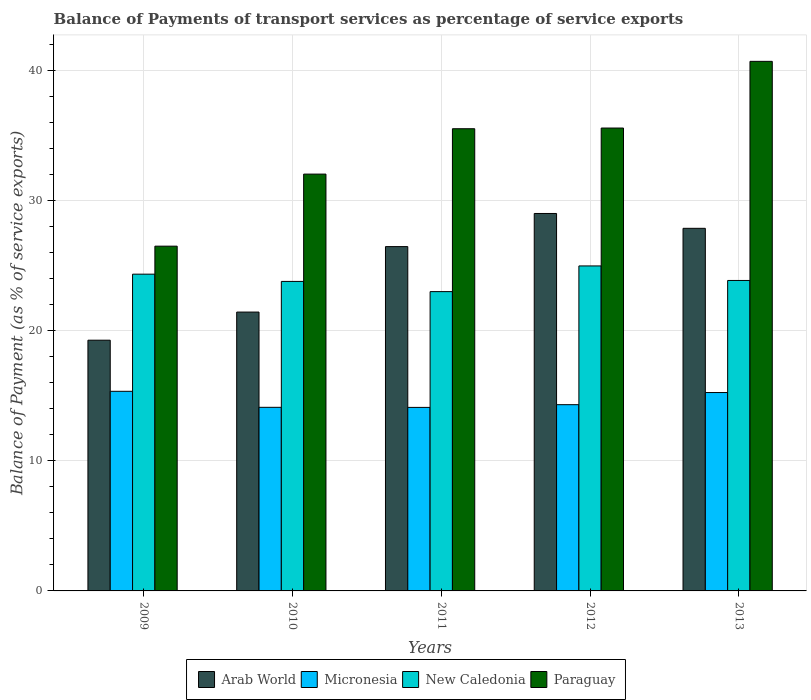How many groups of bars are there?
Give a very brief answer. 5. What is the balance of payments of transport services in Paraguay in 2009?
Provide a succinct answer. 26.48. Across all years, what is the maximum balance of payments of transport services in Arab World?
Make the answer very short. 28.99. Across all years, what is the minimum balance of payments of transport services in Paraguay?
Your response must be concise. 26.48. In which year was the balance of payments of transport services in Micronesia minimum?
Keep it short and to the point. 2011. What is the total balance of payments of transport services in Micronesia in the graph?
Keep it short and to the point. 73.06. What is the difference between the balance of payments of transport services in New Caledonia in 2009 and that in 2013?
Your answer should be compact. 0.48. What is the difference between the balance of payments of transport services in Micronesia in 2009 and the balance of payments of transport services in Arab World in 2013?
Keep it short and to the point. -12.52. What is the average balance of payments of transport services in New Caledonia per year?
Give a very brief answer. 23.98. In the year 2011, what is the difference between the balance of payments of transport services in Micronesia and balance of payments of transport services in Arab World?
Your answer should be compact. -12.35. What is the ratio of the balance of payments of transport services in Paraguay in 2010 to that in 2011?
Your response must be concise. 0.9. Is the balance of payments of transport services in Arab World in 2009 less than that in 2010?
Make the answer very short. Yes. Is the difference between the balance of payments of transport services in Micronesia in 2012 and 2013 greater than the difference between the balance of payments of transport services in Arab World in 2012 and 2013?
Offer a very short reply. No. What is the difference between the highest and the second highest balance of payments of transport services in Arab World?
Your response must be concise. 1.14. What is the difference between the highest and the lowest balance of payments of transport services in Paraguay?
Ensure brevity in your answer.  14.19. In how many years, is the balance of payments of transport services in Paraguay greater than the average balance of payments of transport services in Paraguay taken over all years?
Provide a succinct answer. 3. Is the sum of the balance of payments of transport services in Paraguay in 2010 and 2013 greater than the maximum balance of payments of transport services in New Caledonia across all years?
Ensure brevity in your answer.  Yes. What does the 1st bar from the left in 2011 represents?
Provide a succinct answer. Arab World. What does the 3rd bar from the right in 2013 represents?
Your answer should be compact. Micronesia. Are all the bars in the graph horizontal?
Your answer should be very brief. No. How many years are there in the graph?
Offer a very short reply. 5. Are the values on the major ticks of Y-axis written in scientific E-notation?
Give a very brief answer. No. Does the graph contain any zero values?
Ensure brevity in your answer.  No. Does the graph contain grids?
Keep it short and to the point. Yes. Where does the legend appear in the graph?
Make the answer very short. Bottom center. How many legend labels are there?
Your answer should be very brief. 4. How are the legend labels stacked?
Provide a short and direct response. Horizontal. What is the title of the graph?
Offer a terse response. Balance of Payments of transport services as percentage of service exports. What is the label or title of the X-axis?
Ensure brevity in your answer.  Years. What is the label or title of the Y-axis?
Give a very brief answer. Balance of Payment (as % of service exports). What is the Balance of Payment (as % of service exports) of Arab World in 2009?
Offer a terse response. 19.25. What is the Balance of Payment (as % of service exports) in Micronesia in 2009?
Your answer should be compact. 15.33. What is the Balance of Payment (as % of service exports) of New Caledonia in 2009?
Ensure brevity in your answer.  24.33. What is the Balance of Payment (as % of service exports) of Paraguay in 2009?
Offer a terse response. 26.48. What is the Balance of Payment (as % of service exports) of Arab World in 2010?
Offer a very short reply. 21.41. What is the Balance of Payment (as % of service exports) in Micronesia in 2010?
Provide a short and direct response. 14.1. What is the Balance of Payment (as % of service exports) of New Caledonia in 2010?
Keep it short and to the point. 23.77. What is the Balance of Payment (as % of service exports) in Paraguay in 2010?
Your answer should be compact. 32.01. What is the Balance of Payment (as % of service exports) of Arab World in 2011?
Your response must be concise. 26.44. What is the Balance of Payment (as % of service exports) in Micronesia in 2011?
Offer a very short reply. 14.09. What is the Balance of Payment (as % of service exports) of New Caledonia in 2011?
Your answer should be compact. 22.98. What is the Balance of Payment (as % of service exports) in Paraguay in 2011?
Your response must be concise. 35.49. What is the Balance of Payment (as % of service exports) of Arab World in 2012?
Provide a short and direct response. 28.99. What is the Balance of Payment (as % of service exports) of Micronesia in 2012?
Make the answer very short. 14.3. What is the Balance of Payment (as % of service exports) in New Caledonia in 2012?
Offer a terse response. 24.96. What is the Balance of Payment (as % of service exports) in Paraguay in 2012?
Give a very brief answer. 35.55. What is the Balance of Payment (as % of service exports) of Arab World in 2013?
Provide a succinct answer. 27.85. What is the Balance of Payment (as % of service exports) of Micronesia in 2013?
Offer a terse response. 15.23. What is the Balance of Payment (as % of service exports) of New Caledonia in 2013?
Offer a very short reply. 23.84. What is the Balance of Payment (as % of service exports) of Paraguay in 2013?
Ensure brevity in your answer.  40.67. Across all years, what is the maximum Balance of Payment (as % of service exports) in Arab World?
Your answer should be very brief. 28.99. Across all years, what is the maximum Balance of Payment (as % of service exports) in Micronesia?
Offer a very short reply. 15.33. Across all years, what is the maximum Balance of Payment (as % of service exports) of New Caledonia?
Your answer should be compact. 24.96. Across all years, what is the maximum Balance of Payment (as % of service exports) in Paraguay?
Your response must be concise. 40.67. Across all years, what is the minimum Balance of Payment (as % of service exports) in Arab World?
Make the answer very short. 19.25. Across all years, what is the minimum Balance of Payment (as % of service exports) of Micronesia?
Make the answer very short. 14.09. Across all years, what is the minimum Balance of Payment (as % of service exports) of New Caledonia?
Make the answer very short. 22.98. Across all years, what is the minimum Balance of Payment (as % of service exports) in Paraguay?
Provide a succinct answer. 26.48. What is the total Balance of Payment (as % of service exports) in Arab World in the graph?
Provide a short and direct response. 123.94. What is the total Balance of Payment (as % of service exports) in Micronesia in the graph?
Keep it short and to the point. 73.06. What is the total Balance of Payment (as % of service exports) in New Caledonia in the graph?
Make the answer very short. 119.88. What is the total Balance of Payment (as % of service exports) in Paraguay in the graph?
Offer a very short reply. 170.19. What is the difference between the Balance of Payment (as % of service exports) in Arab World in 2009 and that in 2010?
Make the answer very short. -2.16. What is the difference between the Balance of Payment (as % of service exports) in Micronesia in 2009 and that in 2010?
Your response must be concise. 1.23. What is the difference between the Balance of Payment (as % of service exports) of New Caledonia in 2009 and that in 2010?
Your answer should be compact. 0.56. What is the difference between the Balance of Payment (as % of service exports) in Paraguay in 2009 and that in 2010?
Make the answer very short. -5.53. What is the difference between the Balance of Payment (as % of service exports) in Arab World in 2009 and that in 2011?
Your answer should be compact. -7.19. What is the difference between the Balance of Payment (as % of service exports) in Micronesia in 2009 and that in 2011?
Provide a succinct answer. 1.24. What is the difference between the Balance of Payment (as % of service exports) of New Caledonia in 2009 and that in 2011?
Your response must be concise. 1.34. What is the difference between the Balance of Payment (as % of service exports) of Paraguay in 2009 and that in 2011?
Your response must be concise. -9.02. What is the difference between the Balance of Payment (as % of service exports) of Arab World in 2009 and that in 2012?
Provide a succinct answer. -9.73. What is the difference between the Balance of Payment (as % of service exports) of Micronesia in 2009 and that in 2012?
Give a very brief answer. 1.03. What is the difference between the Balance of Payment (as % of service exports) in New Caledonia in 2009 and that in 2012?
Make the answer very short. -0.63. What is the difference between the Balance of Payment (as % of service exports) of Paraguay in 2009 and that in 2012?
Make the answer very short. -9.07. What is the difference between the Balance of Payment (as % of service exports) in Arab World in 2009 and that in 2013?
Give a very brief answer. -8.59. What is the difference between the Balance of Payment (as % of service exports) in Micronesia in 2009 and that in 2013?
Keep it short and to the point. 0.1. What is the difference between the Balance of Payment (as % of service exports) of New Caledonia in 2009 and that in 2013?
Provide a succinct answer. 0.48. What is the difference between the Balance of Payment (as % of service exports) in Paraguay in 2009 and that in 2013?
Your response must be concise. -14.19. What is the difference between the Balance of Payment (as % of service exports) in Arab World in 2010 and that in 2011?
Your response must be concise. -5.03. What is the difference between the Balance of Payment (as % of service exports) of Micronesia in 2010 and that in 2011?
Make the answer very short. 0.01. What is the difference between the Balance of Payment (as % of service exports) in New Caledonia in 2010 and that in 2011?
Provide a succinct answer. 0.78. What is the difference between the Balance of Payment (as % of service exports) of Paraguay in 2010 and that in 2011?
Give a very brief answer. -3.49. What is the difference between the Balance of Payment (as % of service exports) of Arab World in 2010 and that in 2012?
Provide a succinct answer. -7.57. What is the difference between the Balance of Payment (as % of service exports) in Micronesia in 2010 and that in 2012?
Provide a short and direct response. -0.2. What is the difference between the Balance of Payment (as % of service exports) in New Caledonia in 2010 and that in 2012?
Your answer should be compact. -1.19. What is the difference between the Balance of Payment (as % of service exports) in Paraguay in 2010 and that in 2012?
Provide a short and direct response. -3.54. What is the difference between the Balance of Payment (as % of service exports) of Arab World in 2010 and that in 2013?
Provide a succinct answer. -6.43. What is the difference between the Balance of Payment (as % of service exports) of Micronesia in 2010 and that in 2013?
Keep it short and to the point. -1.14. What is the difference between the Balance of Payment (as % of service exports) of New Caledonia in 2010 and that in 2013?
Your answer should be very brief. -0.07. What is the difference between the Balance of Payment (as % of service exports) of Paraguay in 2010 and that in 2013?
Offer a terse response. -8.66. What is the difference between the Balance of Payment (as % of service exports) in Arab World in 2011 and that in 2012?
Offer a very short reply. -2.54. What is the difference between the Balance of Payment (as % of service exports) in Micronesia in 2011 and that in 2012?
Offer a very short reply. -0.21. What is the difference between the Balance of Payment (as % of service exports) of New Caledonia in 2011 and that in 2012?
Your answer should be very brief. -1.97. What is the difference between the Balance of Payment (as % of service exports) in Paraguay in 2011 and that in 2012?
Your response must be concise. -0.05. What is the difference between the Balance of Payment (as % of service exports) in Arab World in 2011 and that in 2013?
Make the answer very short. -1.4. What is the difference between the Balance of Payment (as % of service exports) in Micronesia in 2011 and that in 2013?
Provide a succinct answer. -1.14. What is the difference between the Balance of Payment (as % of service exports) of New Caledonia in 2011 and that in 2013?
Give a very brief answer. -0.86. What is the difference between the Balance of Payment (as % of service exports) in Paraguay in 2011 and that in 2013?
Your answer should be very brief. -5.17. What is the difference between the Balance of Payment (as % of service exports) in Arab World in 2012 and that in 2013?
Provide a short and direct response. 1.14. What is the difference between the Balance of Payment (as % of service exports) of Micronesia in 2012 and that in 2013?
Make the answer very short. -0.93. What is the difference between the Balance of Payment (as % of service exports) of New Caledonia in 2012 and that in 2013?
Offer a terse response. 1.12. What is the difference between the Balance of Payment (as % of service exports) in Paraguay in 2012 and that in 2013?
Give a very brief answer. -5.12. What is the difference between the Balance of Payment (as % of service exports) in Arab World in 2009 and the Balance of Payment (as % of service exports) in Micronesia in 2010?
Your answer should be compact. 5.16. What is the difference between the Balance of Payment (as % of service exports) in Arab World in 2009 and the Balance of Payment (as % of service exports) in New Caledonia in 2010?
Ensure brevity in your answer.  -4.51. What is the difference between the Balance of Payment (as % of service exports) of Arab World in 2009 and the Balance of Payment (as % of service exports) of Paraguay in 2010?
Provide a succinct answer. -12.75. What is the difference between the Balance of Payment (as % of service exports) in Micronesia in 2009 and the Balance of Payment (as % of service exports) in New Caledonia in 2010?
Give a very brief answer. -8.44. What is the difference between the Balance of Payment (as % of service exports) of Micronesia in 2009 and the Balance of Payment (as % of service exports) of Paraguay in 2010?
Provide a short and direct response. -16.68. What is the difference between the Balance of Payment (as % of service exports) of New Caledonia in 2009 and the Balance of Payment (as % of service exports) of Paraguay in 2010?
Your answer should be compact. -7.68. What is the difference between the Balance of Payment (as % of service exports) of Arab World in 2009 and the Balance of Payment (as % of service exports) of Micronesia in 2011?
Your answer should be very brief. 5.16. What is the difference between the Balance of Payment (as % of service exports) of Arab World in 2009 and the Balance of Payment (as % of service exports) of New Caledonia in 2011?
Give a very brief answer. -3.73. What is the difference between the Balance of Payment (as % of service exports) in Arab World in 2009 and the Balance of Payment (as % of service exports) in Paraguay in 2011?
Provide a succinct answer. -16.24. What is the difference between the Balance of Payment (as % of service exports) in Micronesia in 2009 and the Balance of Payment (as % of service exports) in New Caledonia in 2011?
Provide a short and direct response. -7.66. What is the difference between the Balance of Payment (as % of service exports) of Micronesia in 2009 and the Balance of Payment (as % of service exports) of Paraguay in 2011?
Your answer should be compact. -20.16. What is the difference between the Balance of Payment (as % of service exports) of New Caledonia in 2009 and the Balance of Payment (as % of service exports) of Paraguay in 2011?
Provide a succinct answer. -11.17. What is the difference between the Balance of Payment (as % of service exports) of Arab World in 2009 and the Balance of Payment (as % of service exports) of Micronesia in 2012?
Provide a succinct answer. 4.95. What is the difference between the Balance of Payment (as % of service exports) of Arab World in 2009 and the Balance of Payment (as % of service exports) of New Caledonia in 2012?
Keep it short and to the point. -5.7. What is the difference between the Balance of Payment (as % of service exports) in Arab World in 2009 and the Balance of Payment (as % of service exports) in Paraguay in 2012?
Make the answer very short. -16.29. What is the difference between the Balance of Payment (as % of service exports) of Micronesia in 2009 and the Balance of Payment (as % of service exports) of New Caledonia in 2012?
Provide a short and direct response. -9.63. What is the difference between the Balance of Payment (as % of service exports) of Micronesia in 2009 and the Balance of Payment (as % of service exports) of Paraguay in 2012?
Your answer should be very brief. -20.22. What is the difference between the Balance of Payment (as % of service exports) in New Caledonia in 2009 and the Balance of Payment (as % of service exports) in Paraguay in 2012?
Your answer should be very brief. -11.22. What is the difference between the Balance of Payment (as % of service exports) in Arab World in 2009 and the Balance of Payment (as % of service exports) in Micronesia in 2013?
Your answer should be compact. 4.02. What is the difference between the Balance of Payment (as % of service exports) in Arab World in 2009 and the Balance of Payment (as % of service exports) in New Caledonia in 2013?
Make the answer very short. -4.59. What is the difference between the Balance of Payment (as % of service exports) of Arab World in 2009 and the Balance of Payment (as % of service exports) of Paraguay in 2013?
Your answer should be very brief. -21.41. What is the difference between the Balance of Payment (as % of service exports) of Micronesia in 2009 and the Balance of Payment (as % of service exports) of New Caledonia in 2013?
Provide a succinct answer. -8.51. What is the difference between the Balance of Payment (as % of service exports) of Micronesia in 2009 and the Balance of Payment (as % of service exports) of Paraguay in 2013?
Make the answer very short. -25.34. What is the difference between the Balance of Payment (as % of service exports) of New Caledonia in 2009 and the Balance of Payment (as % of service exports) of Paraguay in 2013?
Provide a succinct answer. -16.34. What is the difference between the Balance of Payment (as % of service exports) in Arab World in 2010 and the Balance of Payment (as % of service exports) in Micronesia in 2011?
Provide a succinct answer. 7.32. What is the difference between the Balance of Payment (as % of service exports) of Arab World in 2010 and the Balance of Payment (as % of service exports) of New Caledonia in 2011?
Your response must be concise. -1.57. What is the difference between the Balance of Payment (as % of service exports) of Arab World in 2010 and the Balance of Payment (as % of service exports) of Paraguay in 2011?
Offer a terse response. -14.08. What is the difference between the Balance of Payment (as % of service exports) in Micronesia in 2010 and the Balance of Payment (as % of service exports) in New Caledonia in 2011?
Keep it short and to the point. -8.89. What is the difference between the Balance of Payment (as % of service exports) in Micronesia in 2010 and the Balance of Payment (as % of service exports) in Paraguay in 2011?
Keep it short and to the point. -21.4. What is the difference between the Balance of Payment (as % of service exports) in New Caledonia in 2010 and the Balance of Payment (as % of service exports) in Paraguay in 2011?
Ensure brevity in your answer.  -11.73. What is the difference between the Balance of Payment (as % of service exports) in Arab World in 2010 and the Balance of Payment (as % of service exports) in Micronesia in 2012?
Offer a terse response. 7.11. What is the difference between the Balance of Payment (as % of service exports) of Arab World in 2010 and the Balance of Payment (as % of service exports) of New Caledonia in 2012?
Make the answer very short. -3.54. What is the difference between the Balance of Payment (as % of service exports) of Arab World in 2010 and the Balance of Payment (as % of service exports) of Paraguay in 2012?
Your response must be concise. -14.13. What is the difference between the Balance of Payment (as % of service exports) of Micronesia in 2010 and the Balance of Payment (as % of service exports) of New Caledonia in 2012?
Your response must be concise. -10.86. What is the difference between the Balance of Payment (as % of service exports) of Micronesia in 2010 and the Balance of Payment (as % of service exports) of Paraguay in 2012?
Offer a very short reply. -21.45. What is the difference between the Balance of Payment (as % of service exports) of New Caledonia in 2010 and the Balance of Payment (as % of service exports) of Paraguay in 2012?
Provide a short and direct response. -11.78. What is the difference between the Balance of Payment (as % of service exports) in Arab World in 2010 and the Balance of Payment (as % of service exports) in Micronesia in 2013?
Your response must be concise. 6.18. What is the difference between the Balance of Payment (as % of service exports) in Arab World in 2010 and the Balance of Payment (as % of service exports) in New Caledonia in 2013?
Make the answer very short. -2.43. What is the difference between the Balance of Payment (as % of service exports) of Arab World in 2010 and the Balance of Payment (as % of service exports) of Paraguay in 2013?
Make the answer very short. -19.25. What is the difference between the Balance of Payment (as % of service exports) of Micronesia in 2010 and the Balance of Payment (as % of service exports) of New Caledonia in 2013?
Offer a terse response. -9.74. What is the difference between the Balance of Payment (as % of service exports) of Micronesia in 2010 and the Balance of Payment (as % of service exports) of Paraguay in 2013?
Give a very brief answer. -26.57. What is the difference between the Balance of Payment (as % of service exports) in New Caledonia in 2010 and the Balance of Payment (as % of service exports) in Paraguay in 2013?
Provide a succinct answer. -16.9. What is the difference between the Balance of Payment (as % of service exports) in Arab World in 2011 and the Balance of Payment (as % of service exports) in Micronesia in 2012?
Make the answer very short. 12.14. What is the difference between the Balance of Payment (as % of service exports) of Arab World in 2011 and the Balance of Payment (as % of service exports) of New Caledonia in 2012?
Provide a succinct answer. 1.48. What is the difference between the Balance of Payment (as % of service exports) of Arab World in 2011 and the Balance of Payment (as % of service exports) of Paraguay in 2012?
Provide a short and direct response. -9.11. What is the difference between the Balance of Payment (as % of service exports) of Micronesia in 2011 and the Balance of Payment (as % of service exports) of New Caledonia in 2012?
Make the answer very short. -10.86. What is the difference between the Balance of Payment (as % of service exports) of Micronesia in 2011 and the Balance of Payment (as % of service exports) of Paraguay in 2012?
Your response must be concise. -21.45. What is the difference between the Balance of Payment (as % of service exports) of New Caledonia in 2011 and the Balance of Payment (as % of service exports) of Paraguay in 2012?
Ensure brevity in your answer.  -12.56. What is the difference between the Balance of Payment (as % of service exports) of Arab World in 2011 and the Balance of Payment (as % of service exports) of Micronesia in 2013?
Provide a short and direct response. 11.21. What is the difference between the Balance of Payment (as % of service exports) of Arab World in 2011 and the Balance of Payment (as % of service exports) of New Caledonia in 2013?
Offer a very short reply. 2.6. What is the difference between the Balance of Payment (as % of service exports) in Arab World in 2011 and the Balance of Payment (as % of service exports) in Paraguay in 2013?
Your answer should be very brief. -14.23. What is the difference between the Balance of Payment (as % of service exports) in Micronesia in 2011 and the Balance of Payment (as % of service exports) in New Caledonia in 2013?
Offer a terse response. -9.75. What is the difference between the Balance of Payment (as % of service exports) in Micronesia in 2011 and the Balance of Payment (as % of service exports) in Paraguay in 2013?
Ensure brevity in your answer.  -26.57. What is the difference between the Balance of Payment (as % of service exports) of New Caledonia in 2011 and the Balance of Payment (as % of service exports) of Paraguay in 2013?
Give a very brief answer. -17.68. What is the difference between the Balance of Payment (as % of service exports) in Arab World in 2012 and the Balance of Payment (as % of service exports) in Micronesia in 2013?
Provide a succinct answer. 13.75. What is the difference between the Balance of Payment (as % of service exports) in Arab World in 2012 and the Balance of Payment (as % of service exports) in New Caledonia in 2013?
Provide a short and direct response. 5.14. What is the difference between the Balance of Payment (as % of service exports) of Arab World in 2012 and the Balance of Payment (as % of service exports) of Paraguay in 2013?
Keep it short and to the point. -11.68. What is the difference between the Balance of Payment (as % of service exports) in Micronesia in 2012 and the Balance of Payment (as % of service exports) in New Caledonia in 2013?
Provide a short and direct response. -9.54. What is the difference between the Balance of Payment (as % of service exports) in Micronesia in 2012 and the Balance of Payment (as % of service exports) in Paraguay in 2013?
Give a very brief answer. -26.37. What is the difference between the Balance of Payment (as % of service exports) of New Caledonia in 2012 and the Balance of Payment (as % of service exports) of Paraguay in 2013?
Offer a terse response. -15.71. What is the average Balance of Payment (as % of service exports) of Arab World per year?
Your answer should be very brief. 24.79. What is the average Balance of Payment (as % of service exports) of Micronesia per year?
Offer a very short reply. 14.61. What is the average Balance of Payment (as % of service exports) in New Caledonia per year?
Ensure brevity in your answer.  23.98. What is the average Balance of Payment (as % of service exports) of Paraguay per year?
Give a very brief answer. 34.04. In the year 2009, what is the difference between the Balance of Payment (as % of service exports) in Arab World and Balance of Payment (as % of service exports) in Micronesia?
Your response must be concise. 3.93. In the year 2009, what is the difference between the Balance of Payment (as % of service exports) in Arab World and Balance of Payment (as % of service exports) in New Caledonia?
Offer a very short reply. -5.07. In the year 2009, what is the difference between the Balance of Payment (as % of service exports) in Arab World and Balance of Payment (as % of service exports) in Paraguay?
Your answer should be compact. -7.22. In the year 2009, what is the difference between the Balance of Payment (as % of service exports) in Micronesia and Balance of Payment (as % of service exports) in New Caledonia?
Give a very brief answer. -9. In the year 2009, what is the difference between the Balance of Payment (as % of service exports) of Micronesia and Balance of Payment (as % of service exports) of Paraguay?
Your answer should be very brief. -11.15. In the year 2009, what is the difference between the Balance of Payment (as % of service exports) of New Caledonia and Balance of Payment (as % of service exports) of Paraguay?
Make the answer very short. -2.15. In the year 2010, what is the difference between the Balance of Payment (as % of service exports) in Arab World and Balance of Payment (as % of service exports) in Micronesia?
Provide a short and direct response. 7.32. In the year 2010, what is the difference between the Balance of Payment (as % of service exports) in Arab World and Balance of Payment (as % of service exports) in New Caledonia?
Ensure brevity in your answer.  -2.35. In the year 2010, what is the difference between the Balance of Payment (as % of service exports) of Arab World and Balance of Payment (as % of service exports) of Paraguay?
Give a very brief answer. -10.59. In the year 2010, what is the difference between the Balance of Payment (as % of service exports) of Micronesia and Balance of Payment (as % of service exports) of New Caledonia?
Offer a very short reply. -9.67. In the year 2010, what is the difference between the Balance of Payment (as % of service exports) of Micronesia and Balance of Payment (as % of service exports) of Paraguay?
Provide a short and direct response. -17.91. In the year 2010, what is the difference between the Balance of Payment (as % of service exports) of New Caledonia and Balance of Payment (as % of service exports) of Paraguay?
Keep it short and to the point. -8.24. In the year 2011, what is the difference between the Balance of Payment (as % of service exports) in Arab World and Balance of Payment (as % of service exports) in Micronesia?
Provide a short and direct response. 12.35. In the year 2011, what is the difference between the Balance of Payment (as % of service exports) of Arab World and Balance of Payment (as % of service exports) of New Caledonia?
Provide a short and direct response. 3.46. In the year 2011, what is the difference between the Balance of Payment (as % of service exports) in Arab World and Balance of Payment (as % of service exports) in Paraguay?
Make the answer very short. -9.05. In the year 2011, what is the difference between the Balance of Payment (as % of service exports) of Micronesia and Balance of Payment (as % of service exports) of New Caledonia?
Your answer should be compact. -8.89. In the year 2011, what is the difference between the Balance of Payment (as % of service exports) of Micronesia and Balance of Payment (as % of service exports) of Paraguay?
Provide a succinct answer. -21.4. In the year 2011, what is the difference between the Balance of Payment (as % of service exports) of New Caledonia and Balance of Payment (as % of service exports) of Paraguay?
Provide a succinct answer. -12.51. In the year 2012, what is the difference between the Balance of Payment (as % of service exports) of Arab World and Balance of Payment (as % of service exports) of Micronesia?
Give a very brief answer. 14.68. In the year 2012, what is the difference between the Balance of Payment (as % of service exports) of Arab World and Balance of Payment (as % of service exports) of New Caledonia?
Keep it short and to the point. 4.03. In the year 2012, what is the difference between the Balance of Payment (as % of service exports) of Arab World and Balance of Payment (as % of service exports) of Paraguay?
Your response must be concise. -6.56. In the year 2012, what is the difference between the Balance of Payment (as % of service exports) of Micronesia and Balance of Payment (as % of service exports) of New Caledonia?
Make the answer very short. -10.66. In the year 2012, what is the difference between the Balance of Payment (as % of service exports) in Micronesia and Balance of Payment (as % of service exports) in Paraguay?
Offer a terse response. -21.24. In the year 2012, what is the difference between the Balance of Payment (as % of service exports) in New Caledonia and Balance of Payment (as % of service exports) in Paraguay?
Ensure brevity in your answer.  -10.59. In the year 2013, what is the difference between the Balance of Payment (as % of service exports) in Arab World and Balance of Payment (as % of service exports) in Micronesia?
Your answer should be compact. 12.61. In the year 2013, what is the difference between the Balance of Payment (as % of service exports) in Arab World and Balance of Payment (as % of service exports) in New Caledonia?
Your answer should be very brief. 4. In the year 2013, what is the difference between the Balance of Payment (as % of service exports) in Arab World and Balance of Payment (as % of service exports) in Paraguay?
Ensure brevity in your answer.  -12.82. In the year 2013, what is the difference between the Balance of Payment (as % of service exports) in Micronesia and Balance of Payment (as % of service exports) in New Caledonia?
Give a very brief answer. -8.61. In the year 2013, what is the difference between the Balance of Payment (as % of service exports) in Micronesia and Balance of Payment (as % of service exports) in Paraguay?
Keep it short and to the point. -25.43. In the year 2013, what is the difference between the Balance of Payment (as % of service exports) of New Caledonia and Balance of Payment (as % of service exports) of Paraguay?
Offer a terse response. -16.83. What is the ratio of the Balance of Payment (as % of service exports) in Arab World in 2009 to that in 2010?
Provide a short and direct response. 0.9. What is the ratio of the Balance of Payment (as % of service exports) of Micronesia in 2009 to that in 2010?
Your response must be concise. 1.09. What is the ratio of the Balance of Payment (as % of service exports) of New Caledonia in 2009 to that in 2010?
Your answer should be very brief. 1.02. What is the ratio of the Balance of Payment (as % of service exports) of Paraguay in 2009 to that in 2010?
Your response must be concise. 0.83. What is the ratio of the Balance of Payment (as % of service exports) of Arab World in 2009 to that in 2011?
Offer a very short reply. 0.73. What is the ratio of the Balance of Payment (as % of service exports) in Micronesia in 2009 to that in 2011?
Keep it short and to the point. 1.09. What is the ratio of the Balance of Payment (as % of service exports) of New Caledonia in 2009 to that in 2011?
Your response must be concise. 1.06. What is the ratio of the Balance of Payment (as % of service exports) in Paraguay in 2009 to that in 2011?
Provide a succinct answer. 0.75. What is the ratio of the Balance of Payment (as % of service exports) in Arab World in 2009 to that in 2012?
Make the answer very short. 0.66. What is the ratio of the Balance of Payment (as % of service exports) in Micronesia in 2009 to that in 2012?
Give a very brief answer. 1.07. What is the ratio of the Balance of Payment (as % of service exports) in New Caledonia in 2009 to that in 2012?
Provide a succinct answer. 0.97. What is the ratio of the Balance of Payment (as % of service exports) in Paraguay in 2009 to that in 2012?
Provide a short and direct response. 0.74. What is the ratio of the Balance of Payment (as % of service exports) in Arab World in 2009 to that in 2013?
Offer a very short reply. 0.69. What is the ratio of the Balance of Payment (as % of service exports) in Micronesia in 2009 to that in 2013?
Your answer should be compact. 1.01. What is the ratio of the Balance of Payment (as % of service exports) in New Caledonia in 2009 to that in 2013?
Give a very brief answer. 1.02. What is the ratio of the Balance of Payment (as % of service exports) in Paraguay in 2009 to that in 2013?
Give a very brief answer. 0.65. What is the ratio of the Balance of Payment (as % of service exports) in Arab World in 2010 to that in 2011?
Make the answer very short. 0.81. What is the ratio of the Balance of Payment (as % of service exports) of Micronesia in 2010 to that in 2011?
Provide a short and direct response. 1. What is the ratio of the Balance of Payment (as % of service exports) in New Caledonia in 2010 to that in 2011?
Your answer should be compact. 1.03. What is the ratio of the Balance of Payment (as % of service exports) in Paraguay in 2010 to that in 2011?
Offer a terse response. 0.9. What is the ratio of the Balance of Payment (as % of service exports) of Arab World in 2010 to that in 2012?
Offer a very short reply. 0.74. What is the ratio of the Balance of Payment (as % of service exports) in Micronesia in 2010 to that in 2012?
Provide a short and direct response. 0.99. What is the ratio of the Balance of Payment (as % of service exports) of New Caledonia in 2010 to that in 2012?
Provide a short and direct response. 0.95. What is the ratio of the Balance of Payment (as % of service exports) in Paraguay in 2010 to that in 2012?
Ensure brevity in your answer.  0.9. What is the ratio of the Balance of Payment (as % of service exports) of Arab World in 2010 to that in 2013?
Ensure brevity in your answer.  0.77. What is the ratio of the Balance of Payment (as % of service exports) of Micronesia in 2010 to that in 2013?
Your response must be concise. 0.93. What is the ratio of the Balance of Payment (as % of service exports) of New Caledonia in 2010 to that in 2013?
Provide a succinct answer. 1. What is the ratio of the Balance of Payment (as % of service exports) of Paraguay in 2010 to that in 2013?
Give a very brief answer. 0.79. What is the ratio of the Balance of Payment (as % of service exports) in Arab World in 2011 to that in 2012?
Offer a terse response. 0.91. What is the ratio of the Balance of Payment (as % of service exports) of Micronesia in 2011 to that in 2012?
Give a very brief answer. 0.99. What is the ratio of the Balance of Payment (as % of service exports) in New Caledonia in 2011 to that in 2012?
Provide a succinct answer. 0.92. What is the ratio of the Balance of Payment (as % of service exports) of Paraguay in 2011 to that in 2012?
Your answer should be compact. 1. What is the ratio of the Balance of Payment (as % of service exports) of Arab World in 2011 to that in 2013?
Ensure brevity in your answer.  0.95. What is the ratio of the Balance of Payment (as % of service exports) in Micronesia in 2011 to that in 2013?
Keep it short and to the point. 0.93. What is the ratio of the Balance of Payment (as % of service exports) of New Caledonia in 2011 to that in 2013?
Your answer should be very brief. 0.96. What is the ratio of the Balance of Payment (as % of service exports) in Paraguay in 2011 to that in 2013?
Offer a very short reply. 0.87. What is the ratio of the Balance of Payment (as % of service exports) of Arab World in 2012 to that in 2013?
Provide a short and direct response. 1.04. What is the ratio of the Balance of Payment (as % of service exports) of Micronesia in 2012 to that in 2013?
Your answer should be very brief. 0.94. What is the ratio of the Balance of Payment (as % of service exports) of New Caledonia in 2012 to that in 2013?
Keep it short and to the point. 1.05. What is the ratio of the Balance of Payment (as % of service exports) in Paraguay in 2012 to that in 2013?
Make the answer very short. 0.87. What is the difference between the highest and the second highest Balance of Payment (as % of service exports) of Arab World?
Offer a terse response. 1.14. What is the difference between the highest and the second highest Balance of Payment (as % of service exports) in Micronesia?
Give a very brief answer. 0.1. What is the difference between the highest and the second highest Balance of Payment (as % of service exports) of New Caledonia?
Offer a terse response. 0.63. What is the difference between the highest and the second highest Balance of Payment (as % of service exports) in Paraguay?
Provide a succinct answer. 5.12. What is the difference between the highest and the lowest Balance of Payment (as % of service exports) of Arab World?
Keep it short and to the point. 9.73. What is the difference between the highest and the lowest Balance of Payment (as % of service exports) of Micronesia?
Provide a short and direct response. 1.24. What is the difference between the highest and the lowest Balance of Payment (as % of service exports) in New Caledonia?
Ensure brevity in your answer.  1.97. What is the difference between the highest and the lowest Balance of Payment (as % of service exports) in Paraguay?
Offer a very short reply. 14.19. 